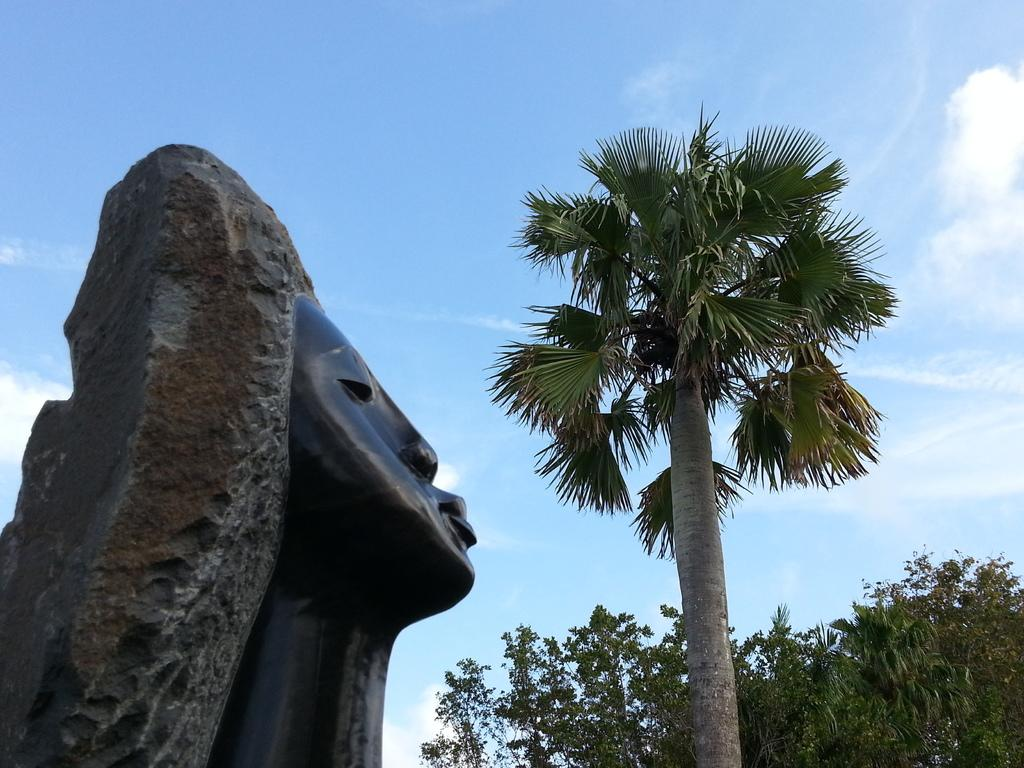What is located on the left side of the image? There is a statue on the left side of the image. What type of vegetation can be seen on the right side of the image? There are trees on the bottom right side of the image. What is visible in the background of the image? The sky is visible in the background of the image. Can you describe the weather condition in the image? The sky appears to be cloudy in the image, suggesting a potentially overcast or rainy condition. What type of spot can be seen on the statue in the image? There is no spot visible on the statue in the image. What type of knife is being used to cut the trees in the image? There is no knife present in the image, nor are any trees being cut. 